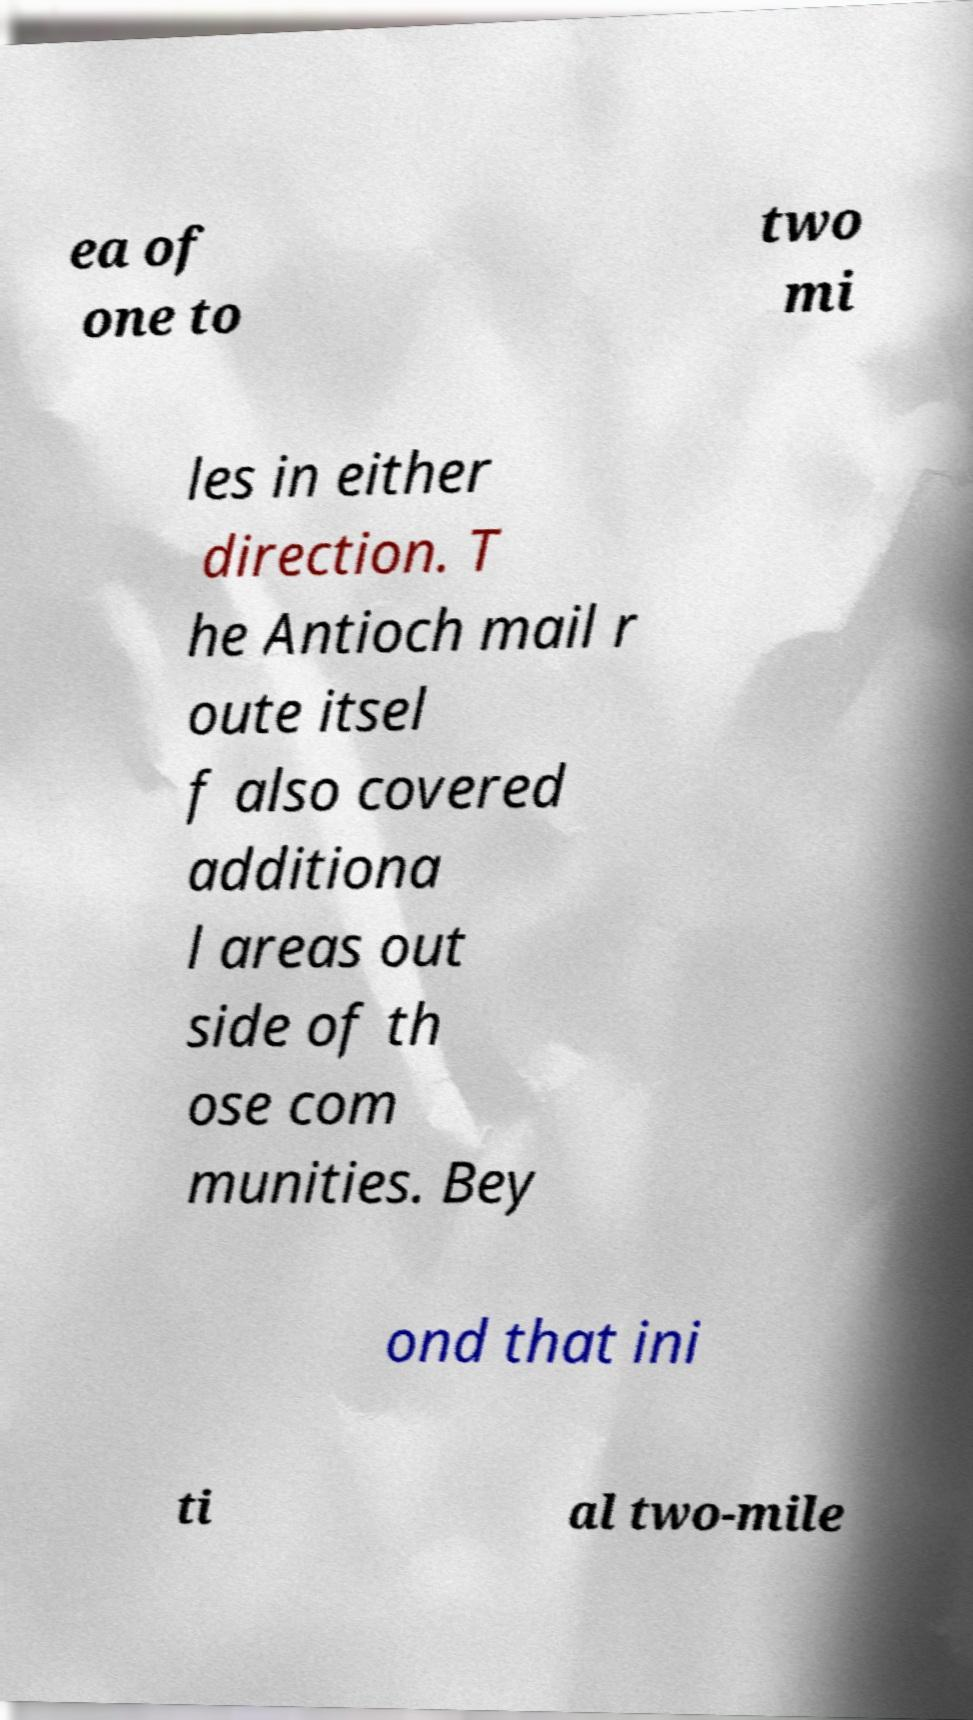Please identify and transcribe the text found in this image. ea of one to two mi les in either direction. T he Antioch mail r oute itsel f also covered additiona l areas out side of th ose com munities. Bey ond that ini ti al two-mile 